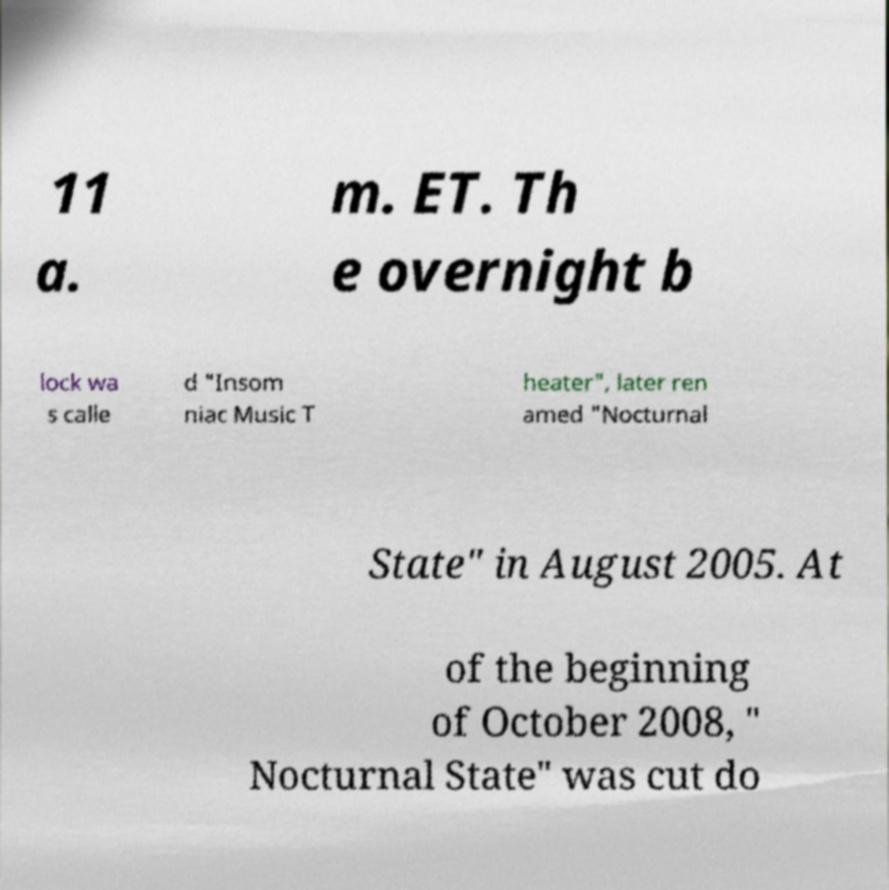There's text embedded in this image that I need extracted. Can you transcribe it verbatim? 11 a. m. ET. Th e overnight b lock wa s calle d "Insom niac Music T heater", later ren amed "Nocturnal State" in August 2005. At of the beginning of October 2008, " Nocturnal State" was cut do 